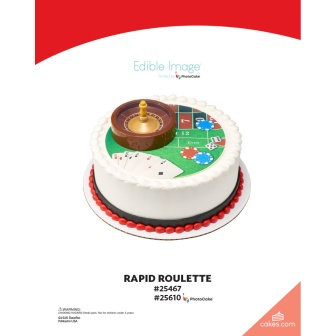What ingredients might have been used to create this cake? To create this casino-themed cake, several key ingredients were likely used: high-quality fondant for the roulette wheel and decorative elements due to its pliability and smooth finish, food-grade coloring for the accurate red, green, black, and brown shades, a rich buttercream icing to achieve the smooth white finish on the cake, and possibly a classic sponge or chocolate cake as the base for its ability to hold the decorative weight without collapsing. The golden center of the roulette wheel might be made from edible gold leaf or gold-colored fondant for an added touch of luxury. 